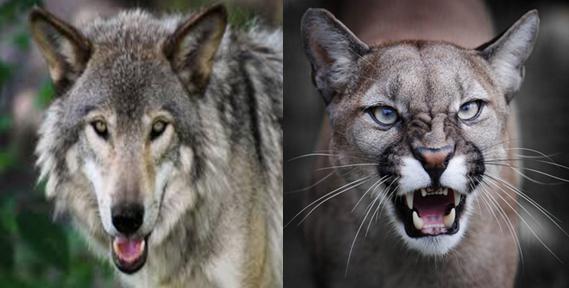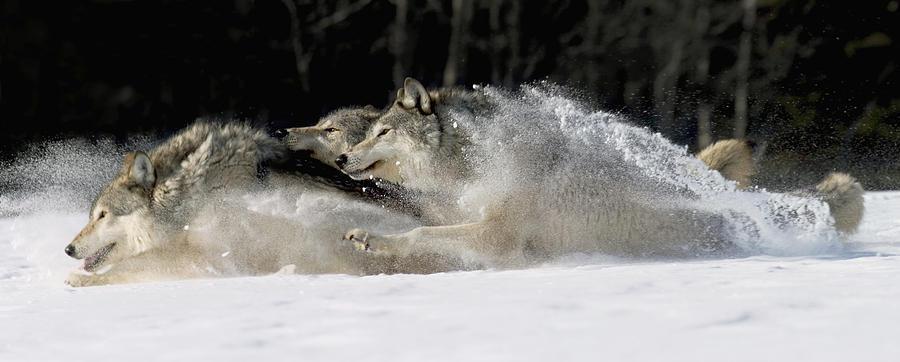The first image is the image on the left, the second image is the image on the right. For the images shown, is this caption "Each image contains exactly two wolves who are close together, and in at least one image, the two wolves are facing off, with snarling mouths." true? Answer yes or no. No. The first image is the image on the left, the second image is the image on the right. Analyze the images presented: Is the assertion "The left image contains exactly two wolves." valid? Answer yes or no. No. 